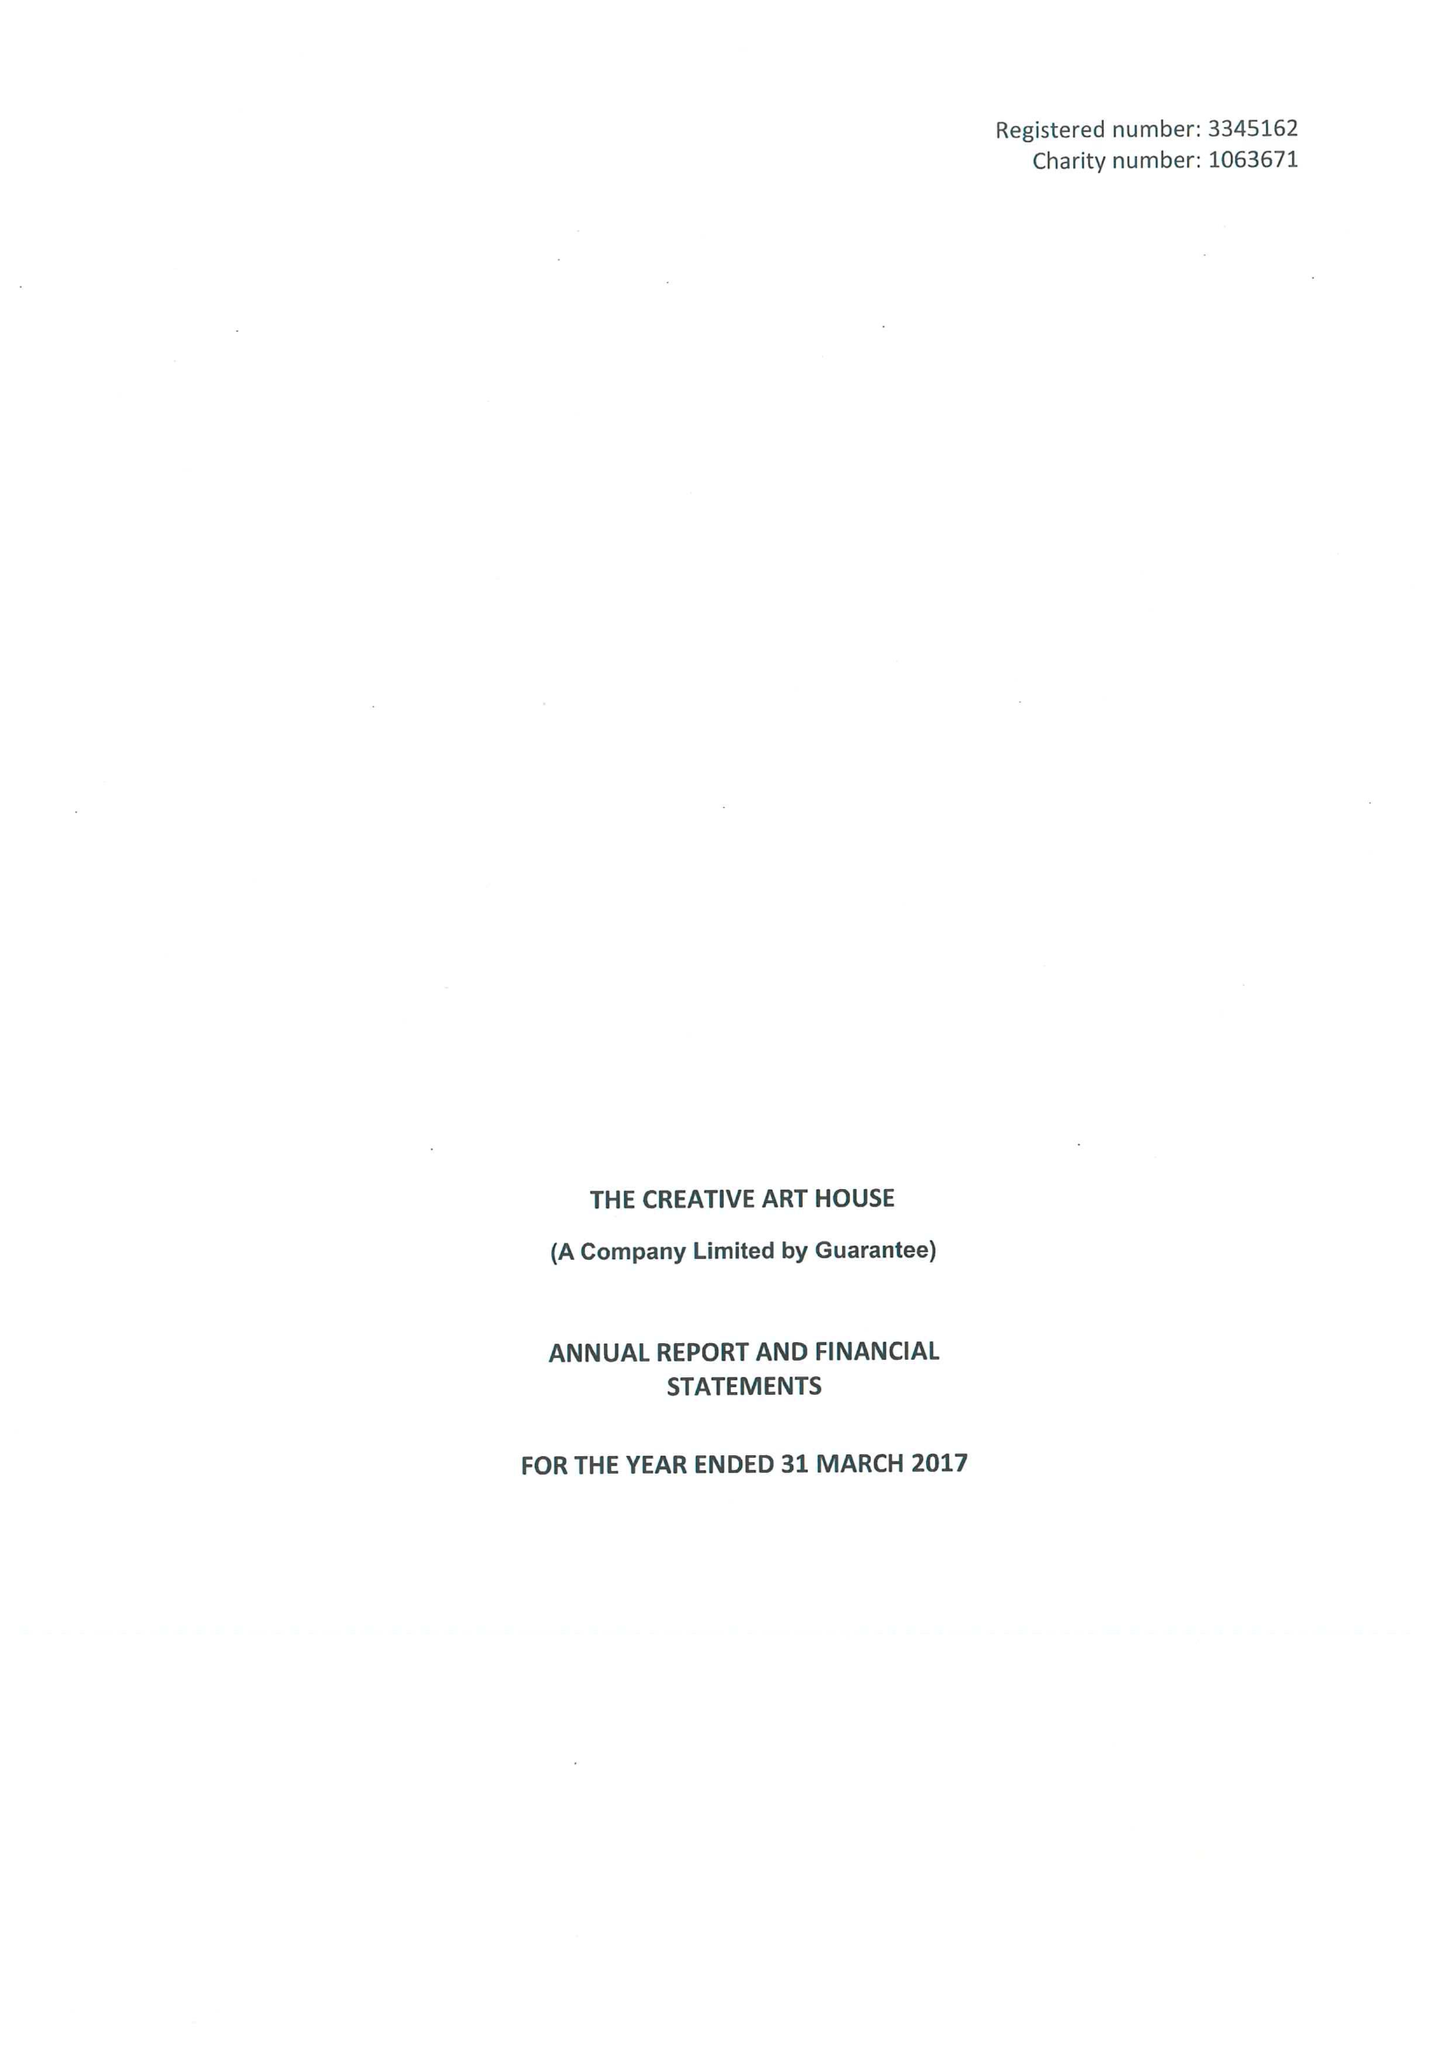What is the value for the address__post_town?
Answer the question using a single word or phrase. WAKEFIELD 